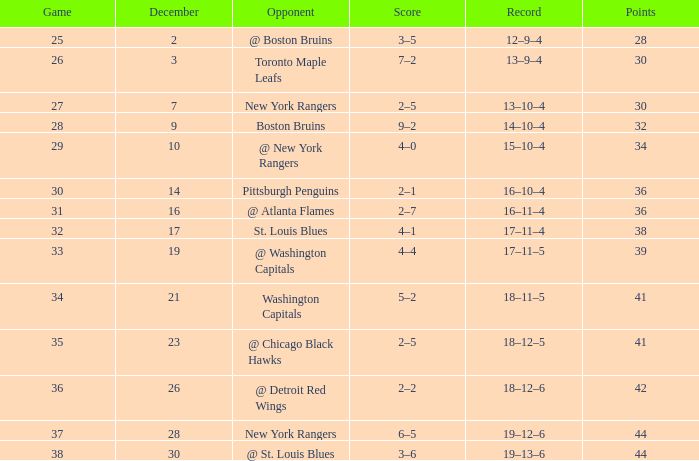Which Game has a Score of 4–1? 32.0. 